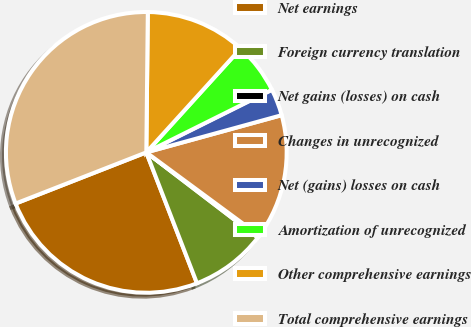Convert chart. <chart><loc_0><loc_0><loc_500><loc_500><pie_chart><fcel>Net earnings<fcel>Foreign currency translation<fcel>Net gains (losses) on cash<fcel>Changes in unrecognized<fcel>Net (gains) losses on cash<fcel>Amortization of unrecognized<fcel>Other comprehensive earnings<fcel>Total comprehensive earnings<nl><fcel>24.94%<fcel>8.74%<fcel>0.27%<fcel>14.38%<fcel>3.09%<fcel>5.91%<fcel>11.56%<fcel>31.11%<nl></chart> 